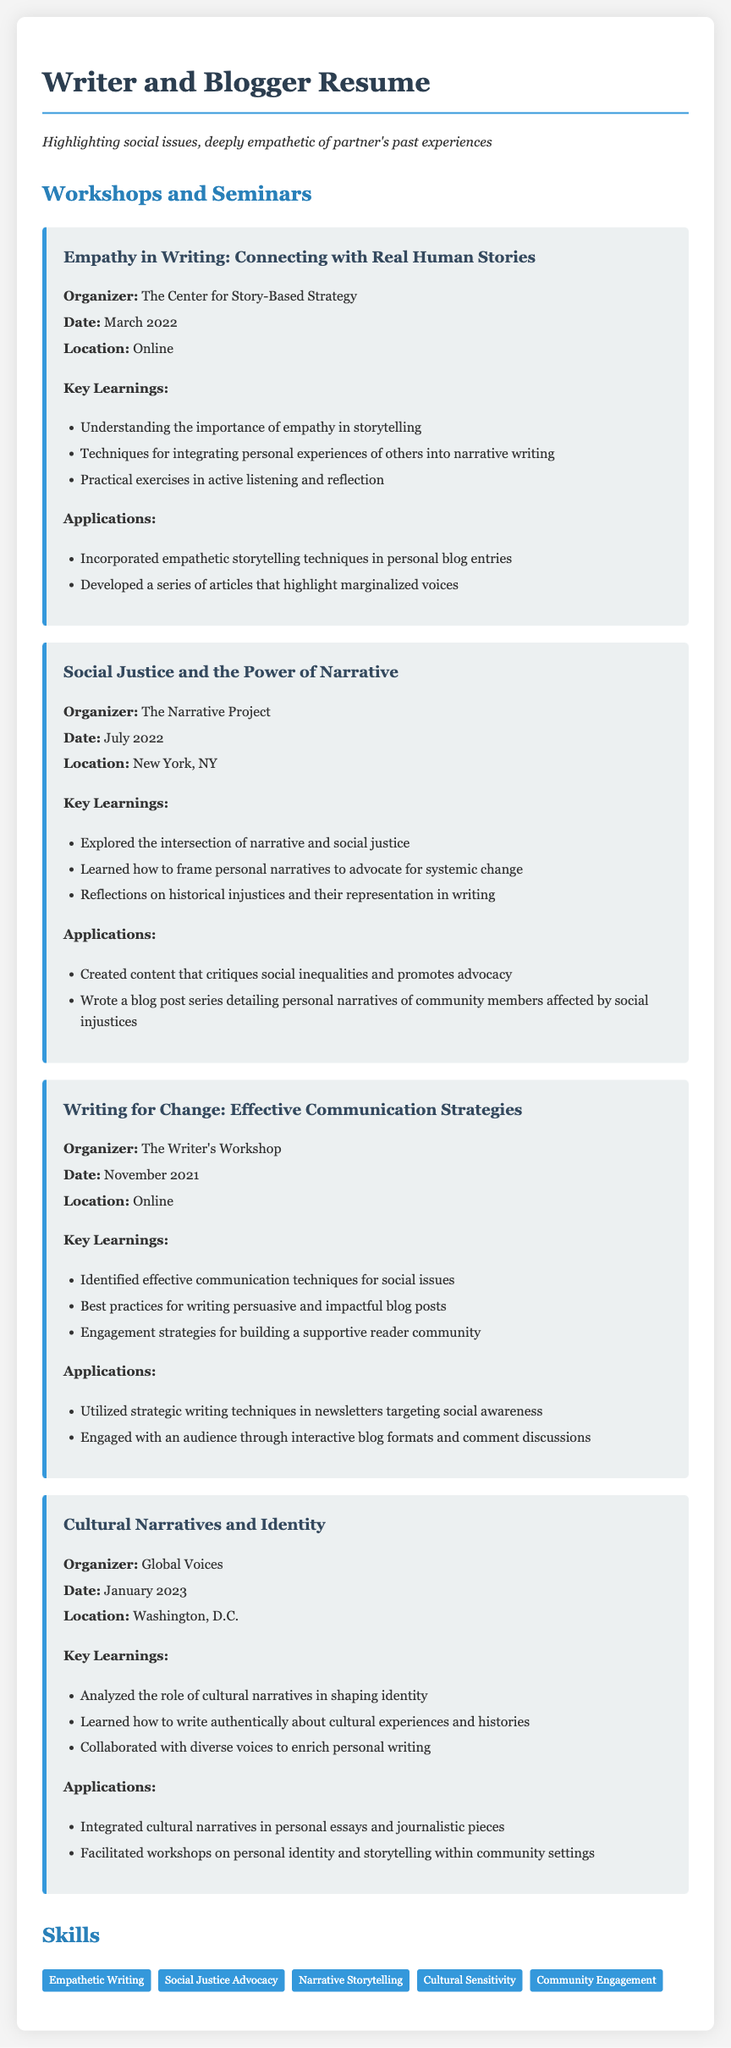What is the title of the first workshop? The title is listed under the first workshop section, which is "Empathy in Writing: Connecting with Real Human Stories."
Answer: Empathy in Writing: Connecting with Real Human Stories Who organized the seminar "Social Justice and the Power of Narrative"? The organizer is specified within the workshop details for that seminar, which is "The Narrative Project."
Answer: The Narrative Project When was the "Writing for Change" workshop held? The date is mentioned in the workshop section which states "November 2021."
Answer: November 2021 What was a key learning from the "Cultural Narratives and Identity" workshop? Key learnings are outlined in each section; one key learning is "Analyzed the role of cultural narratives in shaping identity."
Answer: Analyzed the role of cultural narratives in shaping identity List one application of the "Empathy in Writing" workshop. Applications are described in the workshop details; one application noted is "Incorporated empathetic storytelling techniques in personal blog entries."
Answer: Incorporated empathetic storytelling techniques in personal blog entries How many workshops are listed in the document? The number of workshops can be counted from the document structure, revealing there are four workshops mentioned.
Answer: Four What is a skill mentioned in this resume? Skills are highlighted at the end of the document; one skill mentioned is "Empathetic Writing."
Answer: Empathetic Writing What city hosted the "Cultural Narratives and Identity" workshop? The location for the workshop is specified and it says "Washington, D.C."
Answer: Washington, D.C 